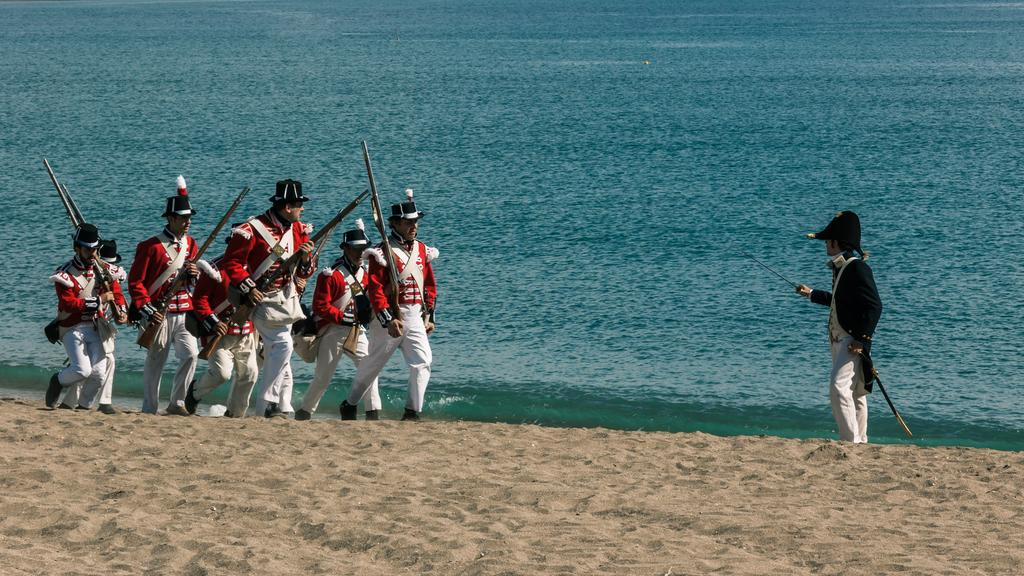What are the main subjects in the image? There are soldiers in the image. What is the terrain like where the soldiers are standing? The soldiers are standing on the sand. Can you describe the location where the image was taken? The location appears to be by the seaside. What type of gold object is being used by the soldiers in the image? There is no gold object visible in the image, and the soldiers are not using any such object. Can you see any pipes in the image? There are no pipes present in the image. 